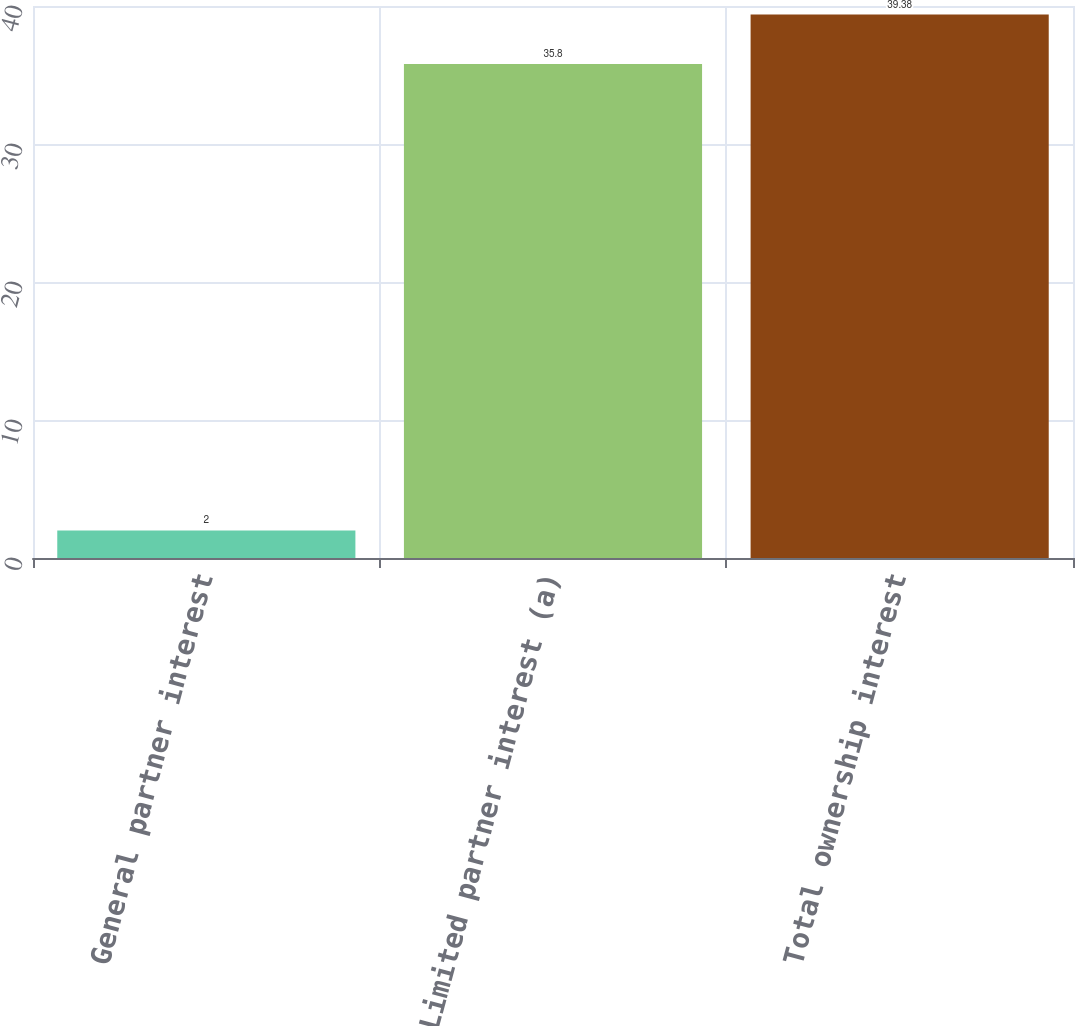Convert chart to OTSL. <chart><loc_0><loc_0><loc_500><loc_500><bar_chart><fcel>General partner interest<fcel>Limited partner interest (a)<fcel>Total ownership interest<nl><fcel>2<fcel>35.8<fcel>39.38<nl></chart> 